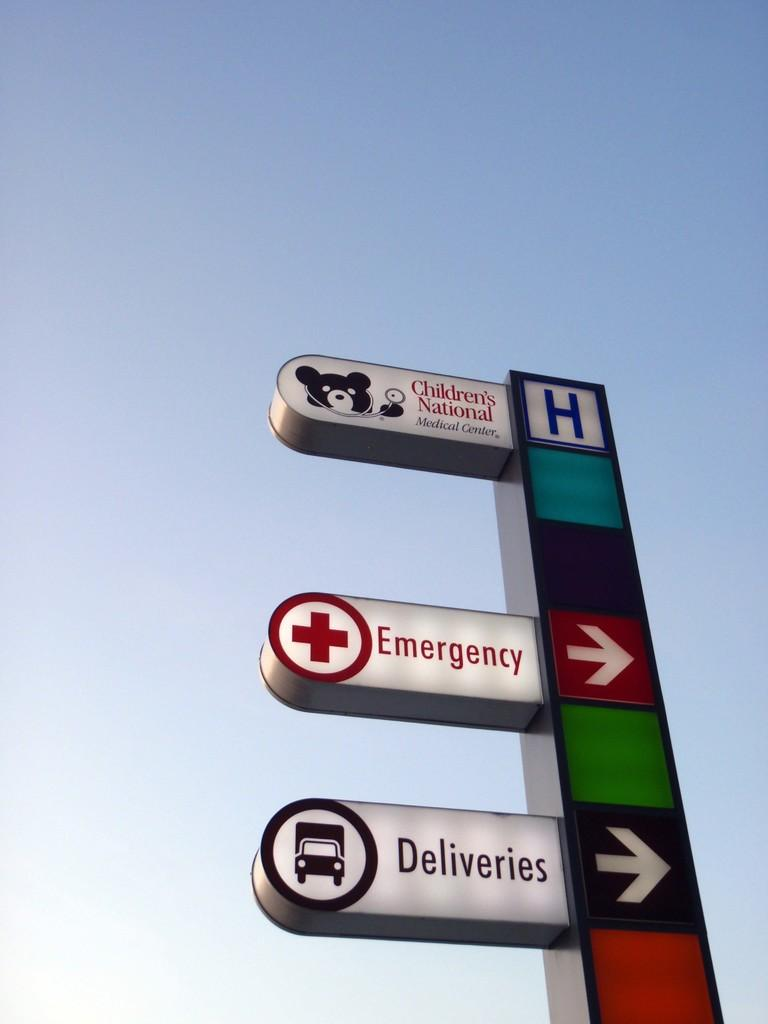What objects are present in the image? There are boards in the image. What can be observed about the appearance of the boards? The boards have multiple colors. What part of the natural environment is visible in the image? The sky is visible in the image. What colors can be seen in the sky? The sky has blue and white colors. Can you describe the tiger's stripes in the image? There is no tiger present in the image; it features boards and a sky with blue and white colors. How many toads are sitting on the boards in the image? There are no toads present in the image; it only features boards and a sky with blue and white colors. 